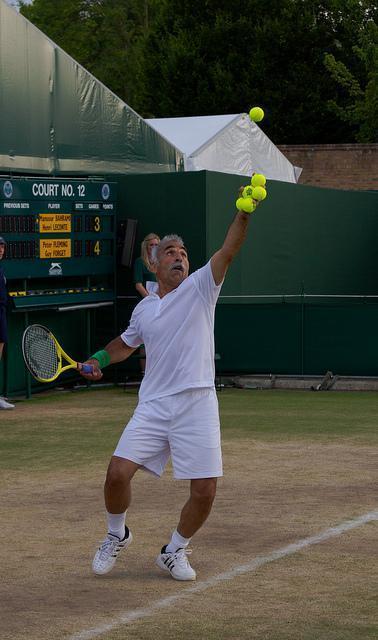How many boats are in the picture?
Give a very brief answer. 0. 